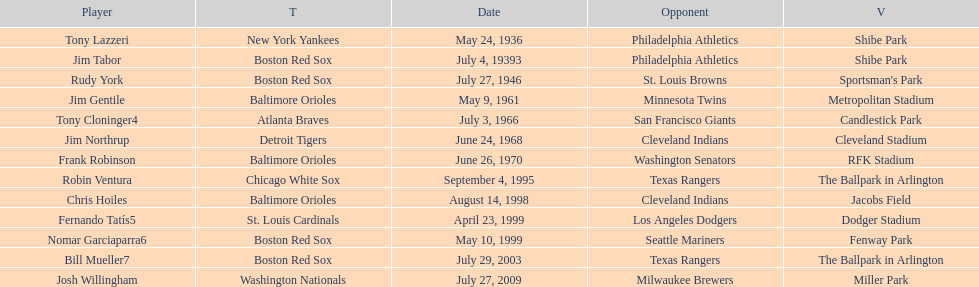What were the dates of each game? May 24, 1936, July 4, 19393, July 27, 1946, May 9, 1961, July 3, 1966, June 24, 1968, June 26, 1970, September 4, 1995, August 14, 1998, April 23, 1999, May 10, 1999, July 29, 2003, July 27, 2009. Who were all of the teams? New York Yankees, Boston Red Sox, Boston Red Sox, Baltimore Orioles, Atlanta Braves, Detroit Tigers, Baltimore Orioles, Chicago White Sox, Baltimore Orioles, St. Louis Cardinals, Boston Red Sox, Boston Red Sox, Washington Nationals. What about their opponents? Philadelphia Athletics, Philadelphia Athletics, St. Louis Browns, Minnesota Twins, San Francisco Giants, Cleveland Indians, Washington Senators, Texas Rangers, Cleveland Indians, Los Angeles Dodgers, Seattle Mariners, Texas Rangers, Milwaukee Brewers. And on which date did the detroit tigers play against the cleveland indians? June 24, 1968. 